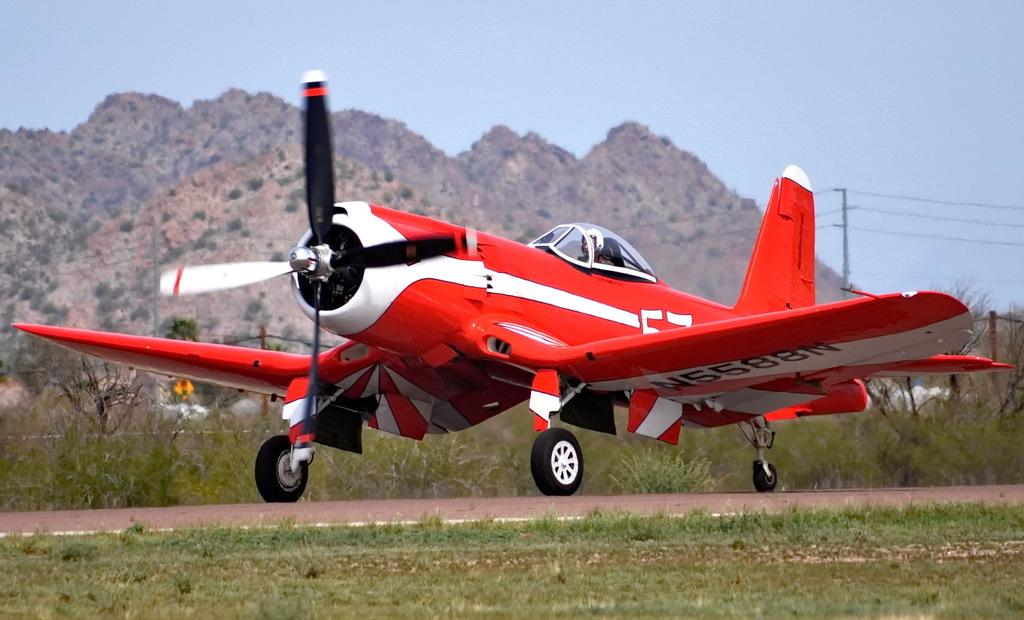<image>
Give a short and clear explanation of the subsequent image. The red airplane taking off from the airfield has a reg number of N5588N 